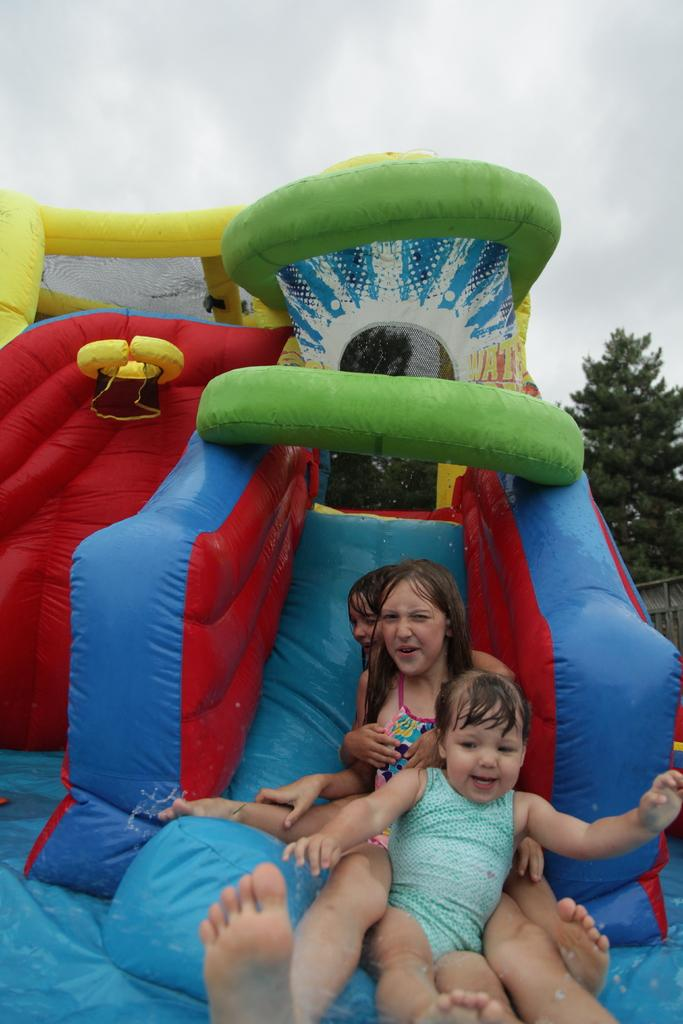Who or what can be seen in the image? There are people in the image. What type of equipment is visible in the image? There is playground equipment in the image. What natural elements are present in the image? There are trees in the image. What can be seen in the background of the image? The sky is visible in the background of the image. What type of frog can be seen jumping on the playground equipment in the image? There is no frog present in the image; it features people and playground equipment. What kind of drug is being administered to the people in the image? There is no indication of any drug or medical treatment in the image. 